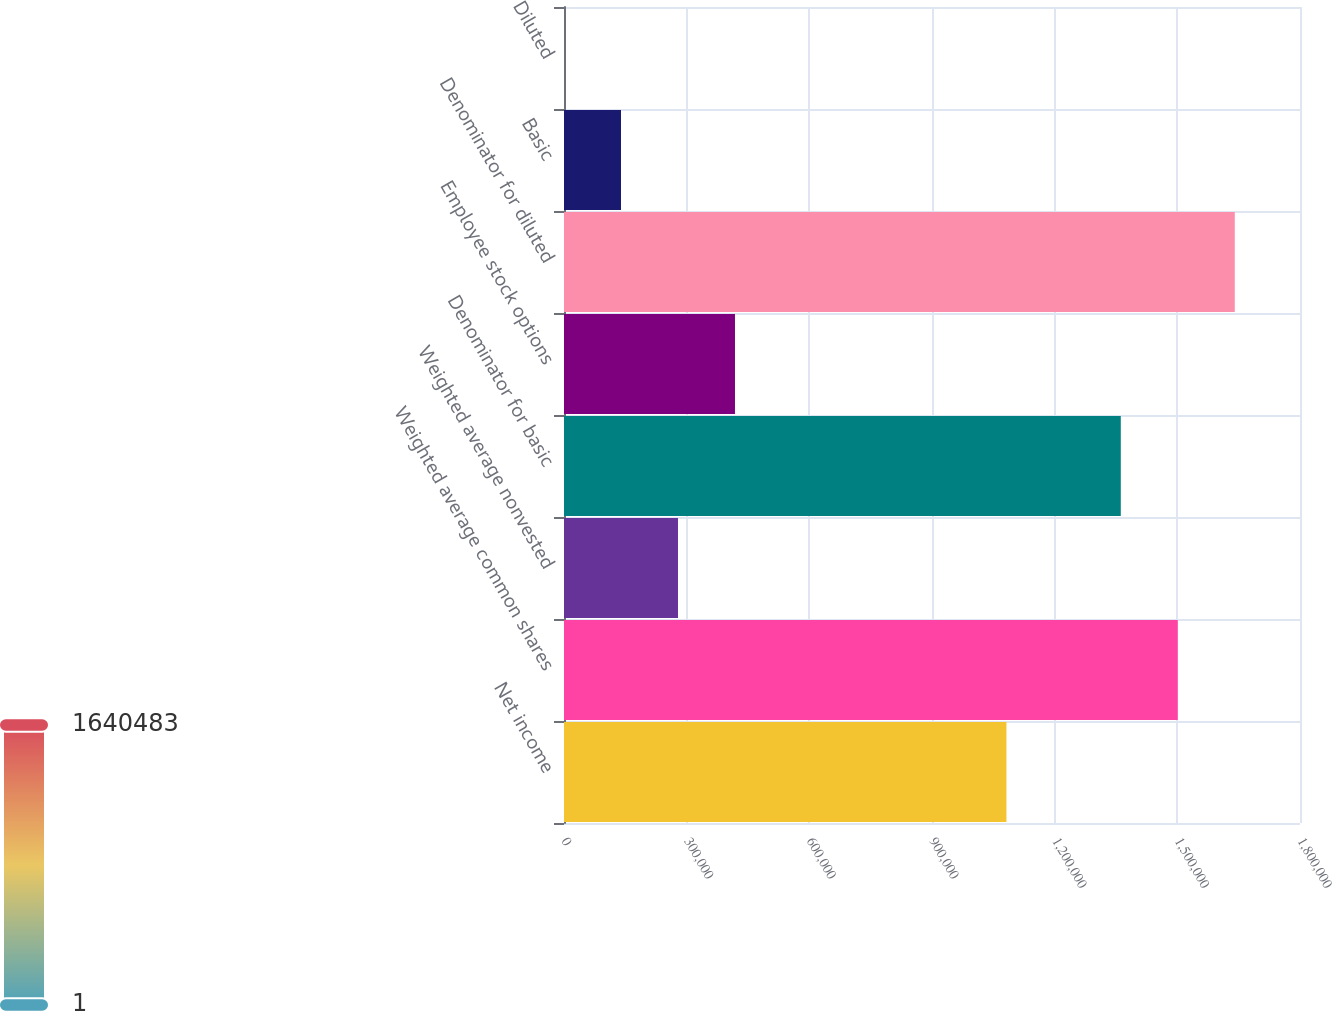Convert chart. <chart><loc_0><loc_0><loc_500><loc_500><bar_chart><fcel>Net income<fcel>Weighted average common shares<fcel>Weighted average nonvested<fcel>Denominator for basic<fcel>Employee stock options<fcel>Denominator for diluted<fcel>Basic<fcel>Diluted<nl><fcel>1.08204e+06<fcel>1.5011e+06<fcel>278776<fcel>1.36171e+06<fcel>418163<fcel>1.64048e+06<fcel>139388<fcel>0.78<nl></chart> 